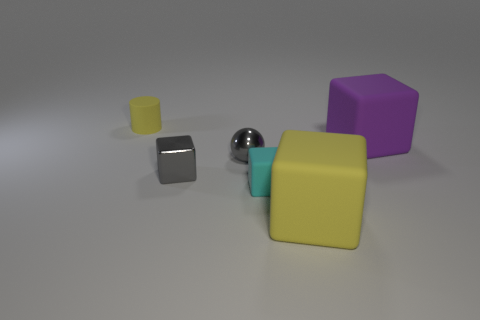Subtract 1 blocks. How many blocks are left? 3 Subtract all blue spheres. Subtract all cyan cubes. How many spheres are left? 1 Add 4 small blue cylinders. How many objects exist? 10 Subtract all cylinders. How many objects are left? 5 Subtract 1 gray spheres. How many objects are left? 5 Subtract all yellow cubes. Subtract all cyan blocks. How many objects are left? 4 Add 5 small gray shiny spheres. How many small gray shiny spheres are left? 6 Add 2 green matte objects. How many green matte objects exist? 2 